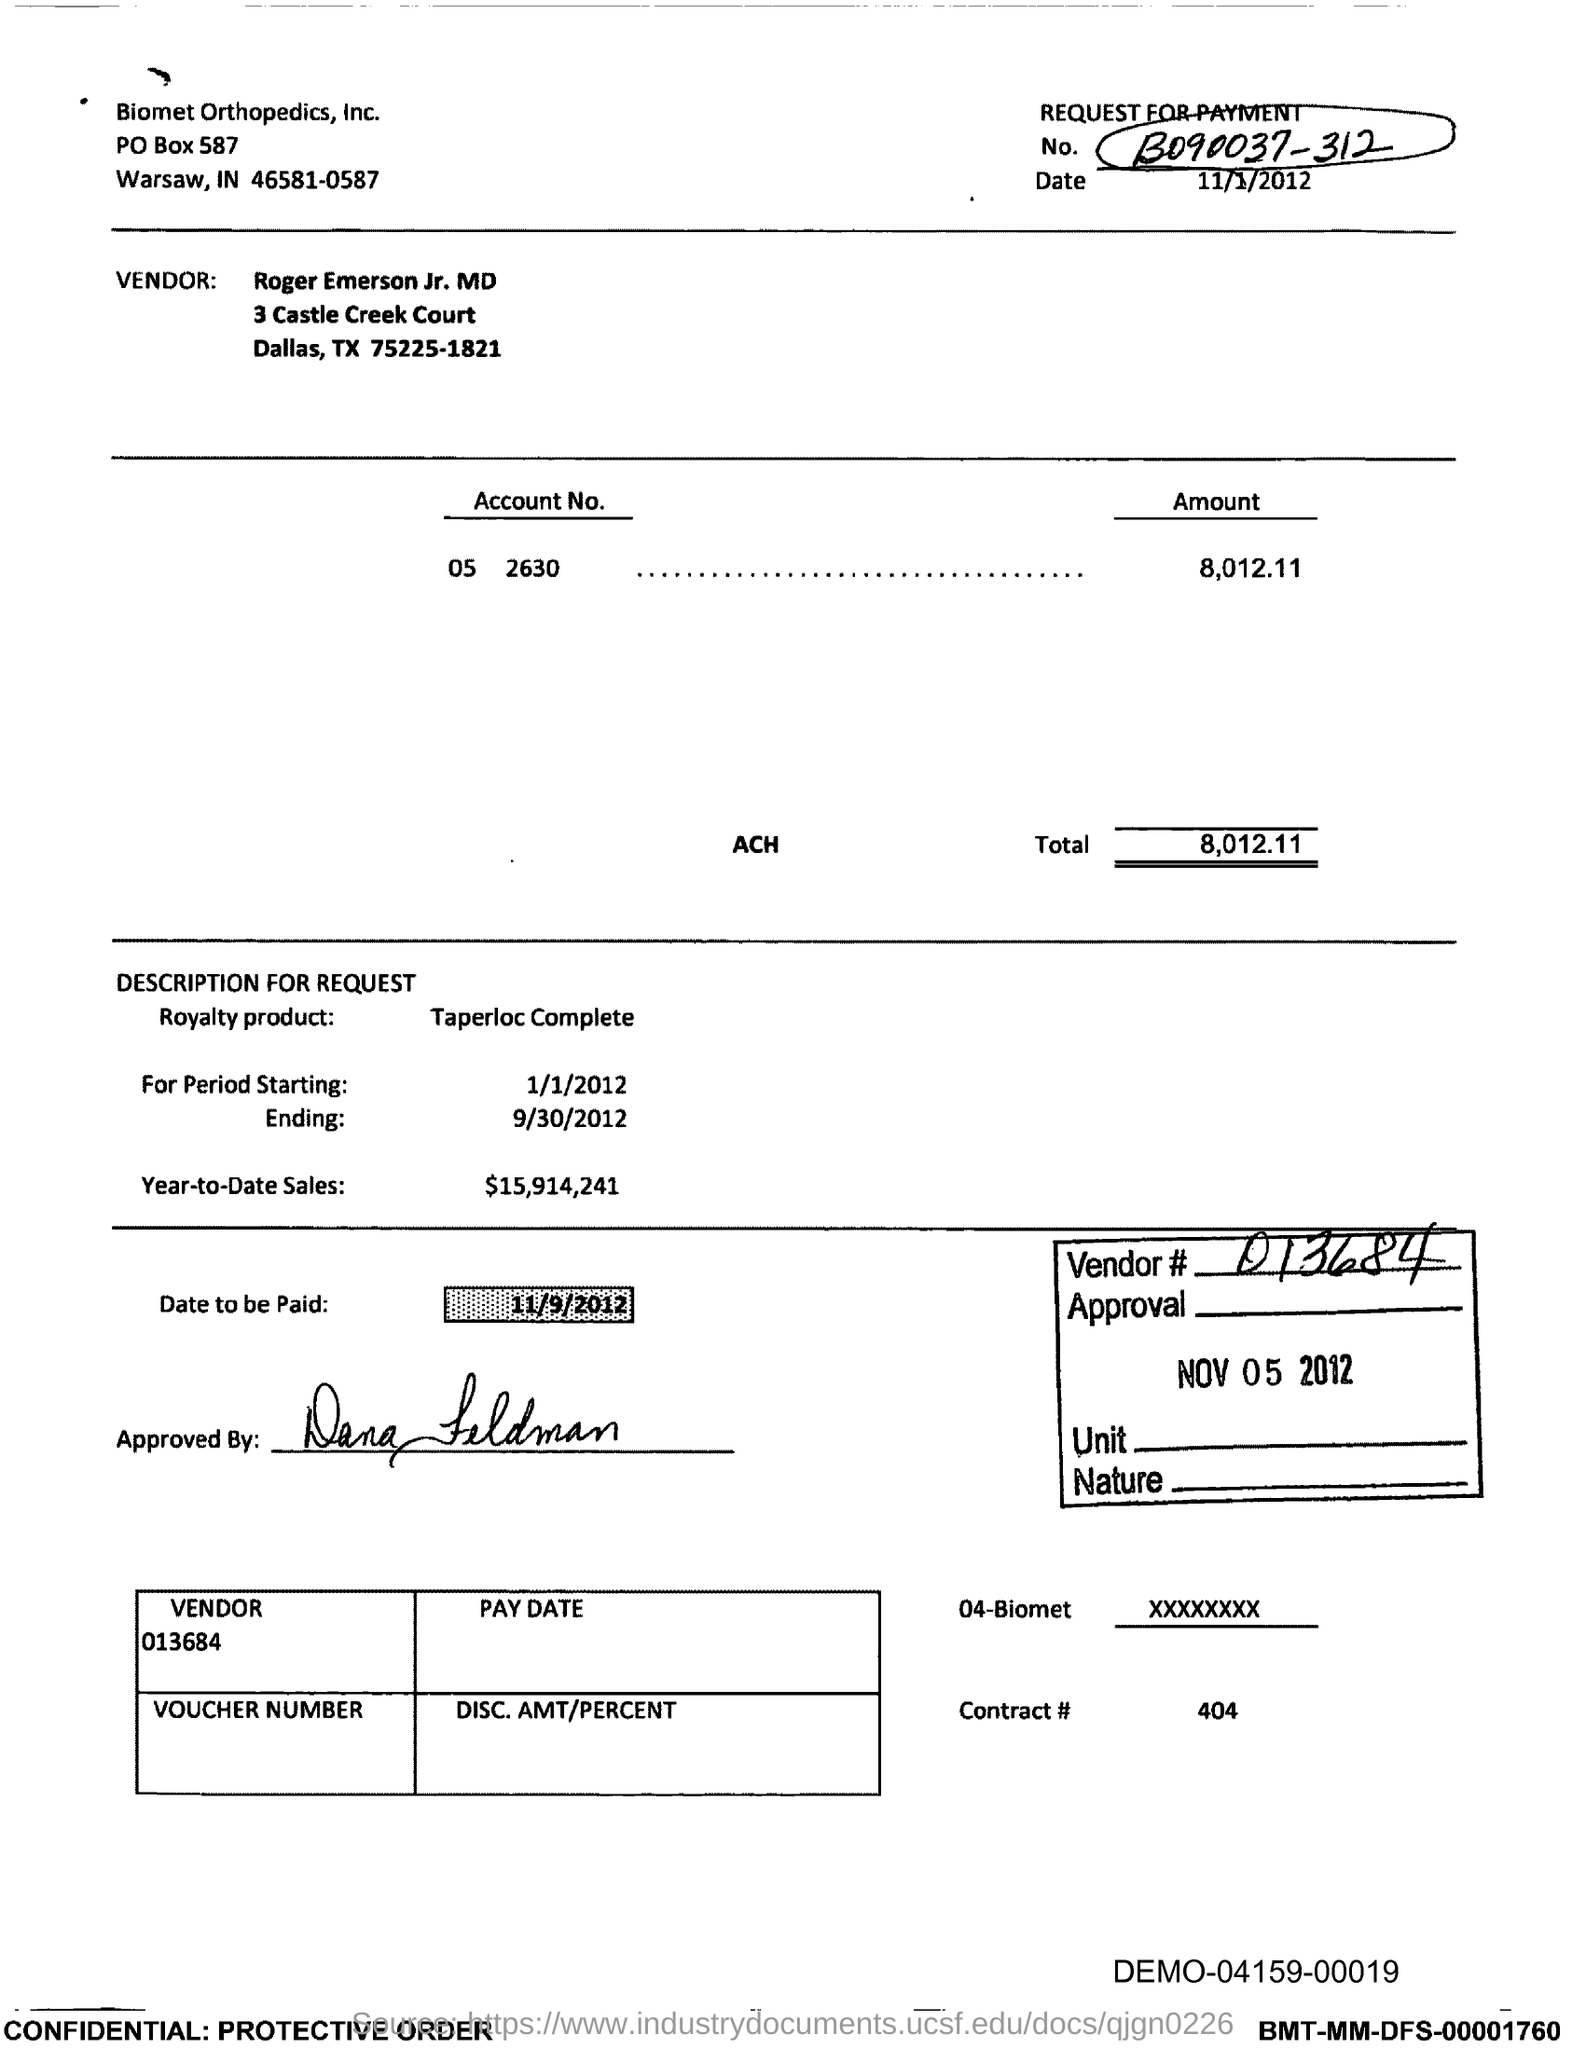Draw attention to some important aspects in this diagram. The total amount in the account is 8,012.11, rounded to the nearest cent. The number written at the top right of the document is B090037-312. What is the date given? It is November 1, 2012. Can you please provide the vendor number for 013684...? On what date is the payment to be made? 